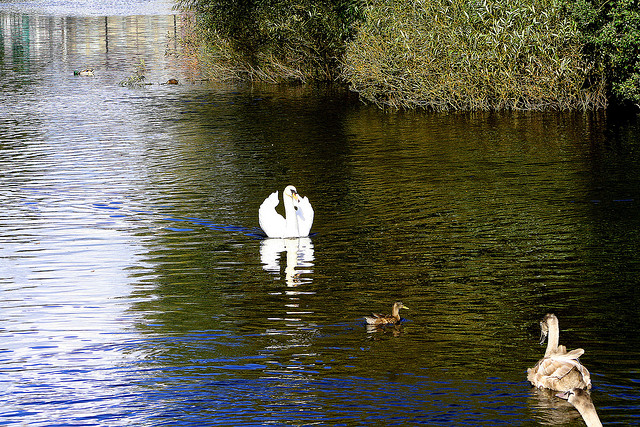Can you describe the environment in which these birds are found? The image shows the birds in a serene lake setting, likely a freshwater ecosystem. This environment is characterized by calm waters, likely rich in aquatic plants and animals, which provide food and shelter for various bird species. The presence of reeds and bushes on the banks further supports a diverse array of wildlife, ideal for birds like swans and ducks. 